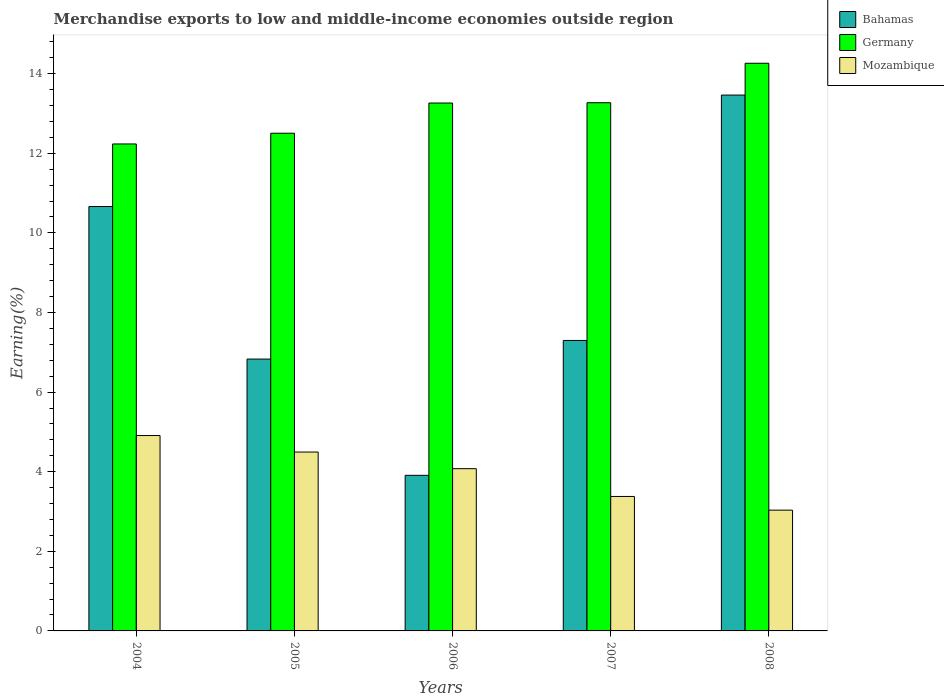How many different coloured bars are there?
Make the answer very short. 3. Are the number of bars on each tick of the X-axis equal?
Your response must be concise. Yes. How many bars are there on the 5th tick from the right?
Make the answer very short. 3. What is the percentage of amount earned from merchandise exports in Mozambique in 2008?
Your answer should be very brief. 3.03. Across all years, what is the maximum percentage of amount earned from merchandise exports in Germany?
Make the answer very short. 14.26. Across all years, what is the minimum percentage of amount earned from merchandise exports in Mozambique?
Your answer should be compact. 3.03. In which year was the percentage of amount earned from merchandise exports in Bahamas maximum?
Make the answer very short. 2008. What is the total percentage of amount earned from merchandise exports in Mozambique in the graph?
Offer a terse response. 19.89. What is the difference between the percentage of amount earned from merchandise exports in Germany in 2006 and that in 2008?
Give a very brief answer. -1. What is the difference between the percentage of amount earned from merchandise exports in Germany in 2008 and the percentage of amount earned from merchandise exports in Bahamas in 2006?
Give a very brief answer. 10.35. What is the average percentage of amount earned from merchandise exports in Mozambique per year?
Provide a succinct answer. 3.98. In the year 2007, what is the difference between the percentage of amount earned from merchandise exports in Bahamas and percentage of amount earned from merchandise exports in Mozambique?
Your answer should be compact. 3.92. In how many years, is the percentage of amount earned from merchandise exports in Mozambique greater than 14.4 %?
Give a very brief answer. 0. What is the ratio of the percentage of amount earned from merchandise exports in Germany in 2004 to that in 2007?
Keep it short and to the point. 0.92. Is the difference between the percentage of amount earned from merchandise exports in Bahamas in 2006 and 2007 greater than the difference between the percentage of amount earned from merchandise exports in Mozambique in 2006 and 2007?
Keep it short and to the point. No. What is the difference between the highest and the second highest percentage of amount earned from merchandise exports in Germany?
Keep it short and to the point. 0.99. What is the difference between the highest and the lowest percentage of amount earned from merchandise exports in Mozambique?
Offer a terse response. 1.87. In how many years, is the percentage of amount earned from merchandise exports in Germany greater than the average percentage of amount earned from merchandise exports in Germany taken over all years?
Offer a very short reply. 3. What does the 3rd bar from the left in 2006 represents?
Keep it short and to the point. Mozambique. What does the 3rd bar from the right in 2005 represents?
Make the answer very short. Bahamas. Does the graph contain grids?
Provide a short and direct response. No. How are the legend labels stacked?
Provide a succinct answer. Vertical. What is the title of the graph?
Offer a terse response. Merchandise exports to low and middle-income economies outside region. Does "Paraguay" appear as one of the legend labels in the graph?
Keep it short and to the point. No. What is the label or title of the Y-axis?
Offer a terse response. Earning(%). What is the Earning(%) of Bahamas in 2004?
Your answer should be compact. 10.66. What is the Earning(%) of Germany in 2004?
Your answer should be compact. 12.23. What is the Earning(%) of Mozambique in 2004?
Offer a very short reply. 4.91. What is the Earning(%) in Bahamas in 2005?
Make the answer very short. 6.83. What is the Earning(%) of Germany in 2005?
Your response must be concise. 12.5. What is the Earning(%) in Mozambique in 2005?
Keep it short and to the point. 4.49. What is the Earning(%) of Bahamas in 2006?
Your answer should be compact. 3.91. What is the Earning(%) in Germany in 2006?
Give a very brief answer. 13.26. What is the Earning(%) of Mozambique in 2006?
Ensure brevity in your answer.  4.08. What is the Earning(%) of Bahamas in 2007?
Offer a very short reply. 7.3. What is the Earning(%) of Germany in 2007?
Your answer should be compact. 13.27. What is the Earning(%) in Mozambique in 2007?
Make the answer very short. 3.38. What is the Earning(%) in Bahamas in 2008?
Provide a short and direct response. 13.46. What is the Earning(%) of Germany in 2008?
Your answer should be very brief. 14.26. What is the Earning(%) of Mozambique in 2008?
Keep it short and to the point. 3.03. Across all years, what is the maximum Earning(%) of Bahamas?
Your answer should be very brief. 13.46. Across all years, what is the maximum Earning(%) in Germany?
Your answer should be compact. 14.26. Across all years, what is the maximum Earning(%) in Mozambique?
Provide a short and direct response. 4.91. Across all years, what is the minimum Earning(%) of Bahamas?
Provide a short and direct response. 3.91. Across all years, what is the minimum Earning(%) of Germany?
Keep it short and to the point. 12.23. Across all years, what is the minimum Earning(%) in Mozambique?
Ensure brevity in your answer.  3.03. What is the total Earning(%) of Bahamas in the graph?
Ensure brevity in your answer.  42.16. What is the total Earning(%) in Germany in the graph?
Your answer should be very brief. 65.53. What is the total Earning(%) of Mozambique in the graph?
Give a very brief answer. 19.89. What is the difference between the Earning(%) of Bahamas in 2004 and that in 2005?
Your response must be concise. 3.83. What is the difference between the Earning(%) of Germany in 2004 and that in 2005?
Your response must be concise. -0.27. What is the difference between the Earning(%) of Mozambique in 2004 and that in 2005?
Your response must be concise. 0.41. What is the difference between the Earning(%) of Bahamas in 2004 and that in 2006?
Provide a short and direct response. 6.75. What is the difference between the Earning(%) of Germany in 2004 and that in 2006?
Your response must be concise. -1.03. What is the difference between the Earning(%) of Mozambique in 2004 and that in 2006?
Offer a very short reply. 0.83. What is the difference between the Earning(%) of Bahamas in 2004 and that in 2007?
Provide a succinct answer. 3.36. What is the difference between the Earning(%) in Germany in 2004 and that in 2007?
Offer a very short reply. -1.04. What is the difference between the Earning(%) in Mozambique in 2004 and that in 2007?
Your response must be concise. 1.53. What is the difference between the Earning(%) of Bahamas in 2004 and that in 2008?
Your answer should be compact. -2.8. What is the difference between the Earning(%) in Germany in 2004 and that in 2008?
Make the answer very short. -2.03. What is the difference between the Earning(%) in Mozambique in 2004 and that in 2008?
Give a very brief answer. 1.87. What is the difference between the Earning(%) of Bahamas in 2005 and that in 2006?
Give a very brief answer. 2.92. What is the difference between the Earning(%) of Germany in 2005 and that in 2006?
Your answer should be compact. -0.76. What is the difference between the Earning(%) of Mozambique in 2005 and that in 2006?
Offer a terse response. 0.42. What is the difference between the Earning(%) in Bahamas in 2005 and that in 2007?
Your answer should be compact. -0.47. What is the difference between the Earning(%) of Germany in 2005 and that in 2007?
Ensure brevity in your answer.  -0.77. What is the difference between the Earning(%) of Mozambique in 2005 and that in 2007?
Provide a succinct answer. 1.12. What is the difference between the Earning(%) in Bahamas in 2005 and that in 2008?
Offer a very short reply. -6.63. What is the difference between the Earning(%) in Germany in 2005 and that in 2008?
Offer a terse response. -1.76. What is the difference between the Earning(%) in Mozambique in 2005 and that in 2008?
Ensure brevity in your answer.  1.46. What is the difference between the Earning(%) in Bahamas in 2006 and that in 2007?
Keep it short and to the point. -3.39. What is the difference between the Earning(%) of Germany in 2006 and that in 2007?
Your answer should be compact. -0.01. What is the difference between the Earning(%) of Mozambique in 2006 and that in 2007?
Offer a terse response. 0.7. What is the difference between the Earning(%) in Bahamas in 2006 and that in 2008?
Keep it short and to the point. -9.55. What is the difference between the Earning(%) in Germany in 2006 and that in 2008?
Offer a very short reply. -1. What is the difference between the Earning(%) of Mozambique in 2006 and that in 2008?
Offer a very short reply. 1.04. What is the difference between the Earning(%) of Bahamas in 2007 and that in 2008?
Ensure brevity in your answer.  -6.16. What is the difference between the Earning(%) of Germany in 2007 and that in 2008?
Make the answer very short. -0.99. What is the difference between the Earning(%) in Mozambique in 2007 and that in 2008?
Your response must be concise. 0.34. What is the difference between the Earning(%) of Bahamas in 2004 and the Earning(%) of Germany in 2005?
Your response must be concise. -1.84. What is the difference between the Earning(%) in Bahamas in 2004 and the Earning(%) in Mozambique in 2005?
Provide a short and direct response. 6.17. What is the difference between the Earning(%) in Germany in 2004 and the Earning(%) in Mozambique in 2005?
Ensure brevity in your answer.  7.74. What is the difference between the Earning(%) of Bahamas in 2004 and the Earning(%) of Germany in 2006?
Make the answer very short. -2.6. What is the difference between the Earning(%) in Bahamas in 2004 and the Earning(%) in Mozambique in 2006?
Offer a terse response. 6.59. What is the difference between the Earning(%) of Germany in 2004 and the Earning(%) of Mozambique in 2006?
Your response must be concise. 8.16. What is the difference between the Earning(%) in Bahamas in 2004 and the Earning(%) in Germany in 2007?
Make the answer very short. -2.61. What is the difference between the Earning(%) of Bahamas in 2004 and the Earning(%) of Mozambique in 2007?
Your answer should be compact. 7.28. What is the difference between the Earning(%) in Germany in 2004 and the Earning(%) in Mozambique in 2007?
Offer a terse response. 8.86. What is the difference between the Earning(%) in Bahamas in 2004 and the Earning(%) in Germany in 2008?
Provide a succinct answer. -3.6. What is the difference between the Earning(%) of Bahamas in 2004 and the Earning(%) of Mozambique in 2008?
Ensure brevity in your answer.  7.63. What is the difference between the Earning(%) of Germany in 2004 and the Earning(%) of Mozambique in 2008?
Your answer should be compact. 9.2. What is the difference between the Earning(%) in Bahamas in 2005 and the Earning(%) in Germany in 2006?
Keep it short and to the point. -6.43. What is the difference between the Earning(%) in Bahamas in 2005 and the Earning(%) in Mozambique in 2006?
Offer a very short reply. 2.75. What is the difference between the Earning(%) of Germany in 2005 and the Earning(%) of Mozambique in 2006?
Provide a short and direct response. 8.43. What is the difference between the Earning(%) in Bahamas in 2005 and the Earning(%) in Germany in 2007?
Offer a terse response. -6.44. What is the difference between the Earning(%) of Bahamas in 2005 and the Earning(%) of Mozambique in 2007?
Keep it short and to the point. 3.45. What is the difference between the Earning(%) of Germany in 2005 and the Earning(%) of Mozambique in 2007?
Your response must be concise. 9.13. What is the difference between the Earning(%) in Bahamas in 2005 and the Earning(%) in Germany in 2008?
Provide a short and direct response. -7.43. What is the difference between the Earning(%) of Bahamas in 2005 and the Earning(%) of Mozambique in 2008?
Ensure brevity in your answer.  3.8. What is the difference between the Earning(%) in Germany in 2005 and the Earning(%) in Mozambique in 2008?
Your answer should be compact. 9.47. What is the difference between the Earning(%) of Bahamas in 2006 and the Earning(%) of Germany in 2007?
Make the answer very short. -9.36. What is the difference between the Earning(%) of Bahamas in 2006 and the Earning(%) of Mozambique in 2007?
Your answer should be compact. 0.53. What is the difference between the Earning(%) of Germany in 2006 and the Earning(%) of Mozambique in 2007?
Make the answer very short. 9.88. What is the difference between the Earning(%) in Bahamas in 2006 and the Earning(%) in Germany in 2008?
Keep it short and to the point. -10.35. What is the difference between the Earning(%) in Germany in 2006 and the Earning(%) in Mozambique in 2008?
Give a very brief answer. 10.23. What is the difference between the Earning(%) in Bahamas in 2007 and the Earning(%) in Germany in 2008?
Ensure brevity in your answer.  -6.96. What is the difference between the Earning(%) in Bahamas in 2007 and the Earning(%) in Mozambique in 2008?
Your answer should be very brief. 4.26. What is the difference between the Earning(%) of Germany in 2007 and the Earning(%) of Mozambique in 2008?
Give a very brief answer. 10.23. What is the average Earning(%) of Bahamas per year?
Offer a very short reply. 8.43. What is the average Earning(%) in Germany per year?
Keep it short and to the point. 13.11. What is the average Earning(%) of Mozambique per year?
Offer a terse response. 3.98. In the year 2004, what is the difference between the Earning(%) of Bahamas and Earning(%) of Germany?
Keep it short and to the point. -1.57. In the year 2004, what is the difference between the Earning(%) of Bahamas and Earning(%) of Mozambique?
Ensure brevity in your answer.  5.75. In the year 2004, what is the difference between the Earning(%) in Germany and Earning(%) in Mozambique?
Offer a terse response. 7.33. In the year 2005, what is the difference between the Earning(%) in Bahamas and Earning(%) in Germany?
Your answer should be compact. -5.67. In the year 2005, what is the difference between the Earning(%) in Bahamas and Earning(%) in Mozambique?
Provide a short and direct response. 2.34. In the year 2005, what is the difference between the Earning(%) in Germany and Earning(%) in Mozambique?
Keep it short and to the point. 8.01. In the year 2006, what is the difference between the Earning(%) of Bahamas and Earning(%) of Germany?
Your answer should be compact. -9.35. In the year 2006, what is the difference between the Earning(%) in Bahamas and Earning(%) in Mozambique?
Provide a succinct answer. -0.17. In the year 2006, what is the difference between the Earning(%) of Germany and Earning(%) of Mozambique?
Provide a short and direct response. 9.19. In the year 2007, what is the difference between the Earning(%) of Bahamas and Earning(%) of Germany?
Your answer should be compact. -5.97. In the year 2007, what is the difference between the Earning(%) in Bahamas and Earning(%) in Mozambique?
Offer a very short reply. 3.92. In the year 2007, what is the difference between the Earning(%) in Germany and Earning(%) in Mozambique?
Ensure brevity in your answer.  9.89. In the year 2008, what is the difference between the Earning(%) of Bahamas and Earning(%) of Germany?
Give a very brief answer. -0.8. In the year 2008, what is the difference between the Earning(%) of Bahamas and Earning(%) of Mozambique?
Keep it short and to the point. 10.43. In the year 2008, what is the difference between the Earning(%) of Germany and Earning(%) of Mozambique?
Ensure brevity in your answer.  11.23. What is the ratio of the Earning(%) in Bahamas in 2004 to that in 2005?
Offer a very short reply. 1.56. What is the ratio of the Earning(%) in Germany in 2004 to that in 2005?
Offer a very short reply. 0.98. What is the ratio of the Earning(%) in Mozambique in 2004 to that in 2005?
Your response must be concise. 1.09. What is the ratio of the Earning(%) in Bahamas in 2004 to that in 2006?
Make the answer very short. 2.73. What is the ratio of the Earning(%) of Germany in 2004 to that in 2006?
Give a very brief answer. 0.92. What is the ratio of the Earning(%) in Mozambique in 2004 to that in 2006?
Keep it short and to the point. 1.2. What is the ratio of the Earning(%) in Bahamas in 2004 to that in 2007?
Your answer should be compact. 1.46. What is the ratio of the Earning(%) of Germany in 2004 to that in 2007?
Make the answer very short. 0.92. What is the ratio of the Earning(%) in Mozambique in 2004 to that in 2007?
Offer a very short reply. 1.45. What is the ratio of the Earning(%) of Bahamas in 2004 to that in 2008?
Your answer should be compact. 0.79. What is the ratio of the Earning(%) in Germany in 2004 to that in 2008?
Make the answer very short. 0.86. What is the ratio of the Earning(%) in Mozambique in 2004 to that in 2008?
Keep it short and to the point. 1.62. What is the ratio of the Earning(%) in Bahamas in 2005 to that in 2006?
Ensure brevity in your answer.  1.75. What is the ratio of the Earning(%) in Germany in 2005 to that in 2006?
Your answer should be compact. 0.94. What is the ratio of the Earning(%) of Mozambique in 2005 to that in 2006?
Offer a very short reply. 1.1. What is the ratio of the Earning(%) of Bahamas in 2005 to that in 2007?
Give a very brief answer. 0.94. What is the ratio of the Earning(%) in Germany in 2005 to that in 2007?
Keep it short and to the point. 0.94. What is the ratio of the Earning(%) of Mozambique in 2005 to that in 2007?
Offer a terse response. 1.33. What is the ratio of the Earning(%) of Bahamas in 2005 to that in 2008?
Provide a short and direct response. 0.51. What is the ratio of the Earning(%) in Germany in 2005 to that in 2008?
Your answer should be compact. 0.88. What is the ratio of the Earning(%) of Mozambique in 2005 to that in 2008?
Make the answer very short. 1.48. What is the ratio of the Earning(%) of Bahamas in 2006 to that in 2007?
Your answer should be compact. 0.54. What is the ratio of the Earning(%) in Mozambique in 2006 to that in 2007?
Offer a terse response. 1.21. What is the ratio of the Earning(%) of Bahamas in 2006 to that in 2008?
Offer a very short reply. 0.29. What is the ratio of the Earning(%) of Mozambique in 2006 to that in 2008?
Ensure brevity in your answer.  1.34. What is the ratio of the Earning(%) in Bahamas in 2007 to that in 2008?
Your response must be concise. 0.54. What is the ratio of the Earning(%) in Germany in 2007 to that in 2008?
Offer a very short reply. 0.93. What is the ratio of the Earning(%) in Mozambique in 2007 to that in 2008?
Keep it short and to the point. 1.11. What is the difference between the highest and the second highest Earning(%) in Bahamas?
Your response must be concise. 2.8. What is the difference between the highest and the second highest Earning(%) in Germany?
Your answer should be very brief. 0.99. What is the difference between the highest and the second highest Earning(%) in Mozambique?
Provide a short and direct response. 0.41. What is the difference between the highest and the lowest Earning(%) of Bahamas?
Your answer should be very brief. 9.55. What is the difference between the highest and the lowest Earning(%) in Germany?
Your answer should be compact. 2.03. What is the difference between the highest and the lowest Earning(%) in Mozambique?
Your answer should be very brief. 1.87. 